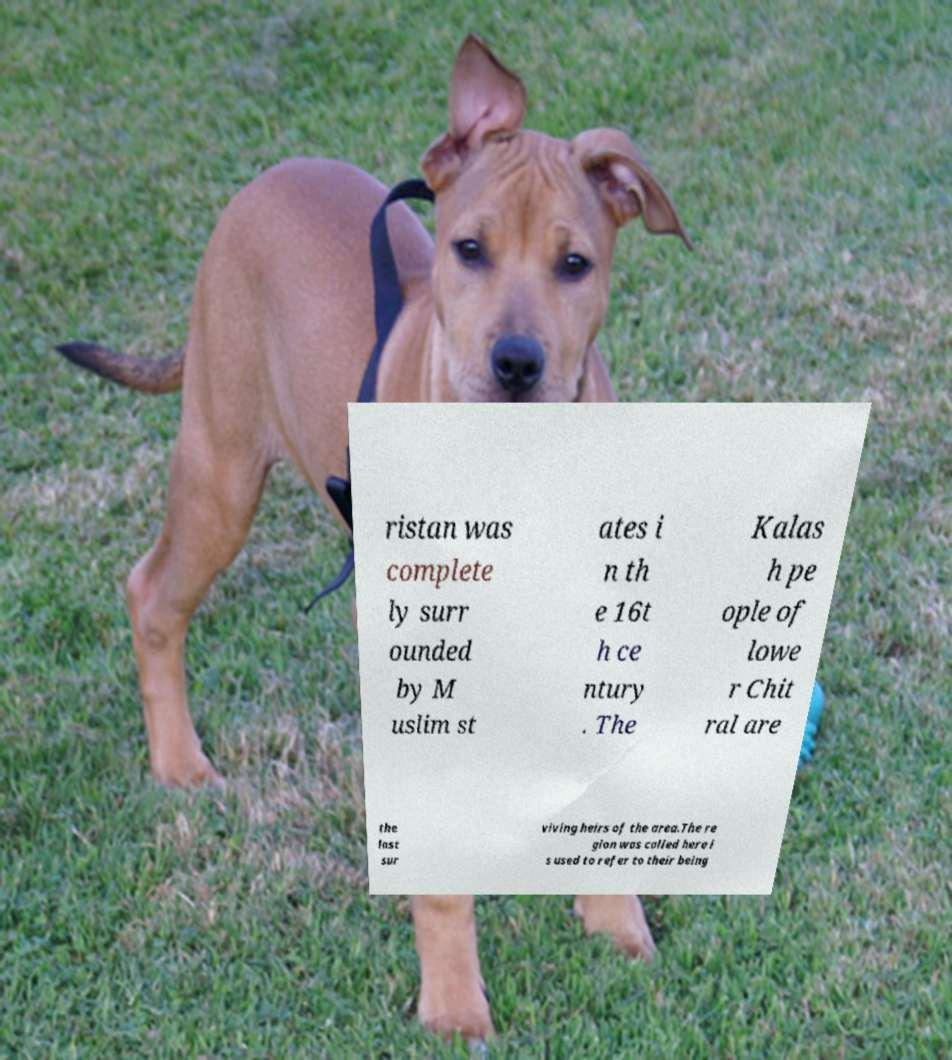Please read and relay the text visible in this image. What does it say? ristan was complete ly surr ounded by M uslim st ates i n th e 16t h ce ntury . The Kalas h pe ople of lowe r Chit ral are the last sur viving heirs of the area.The re gion was called here i s used to refer to their being 